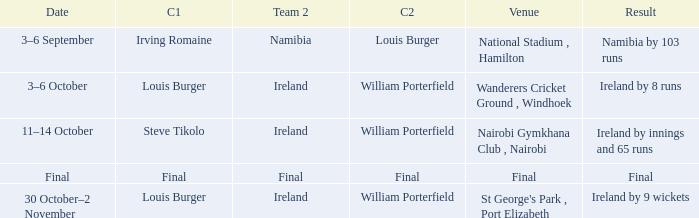Which Result has a Captain 2 of louis burger? Namibia by 103 runs. 